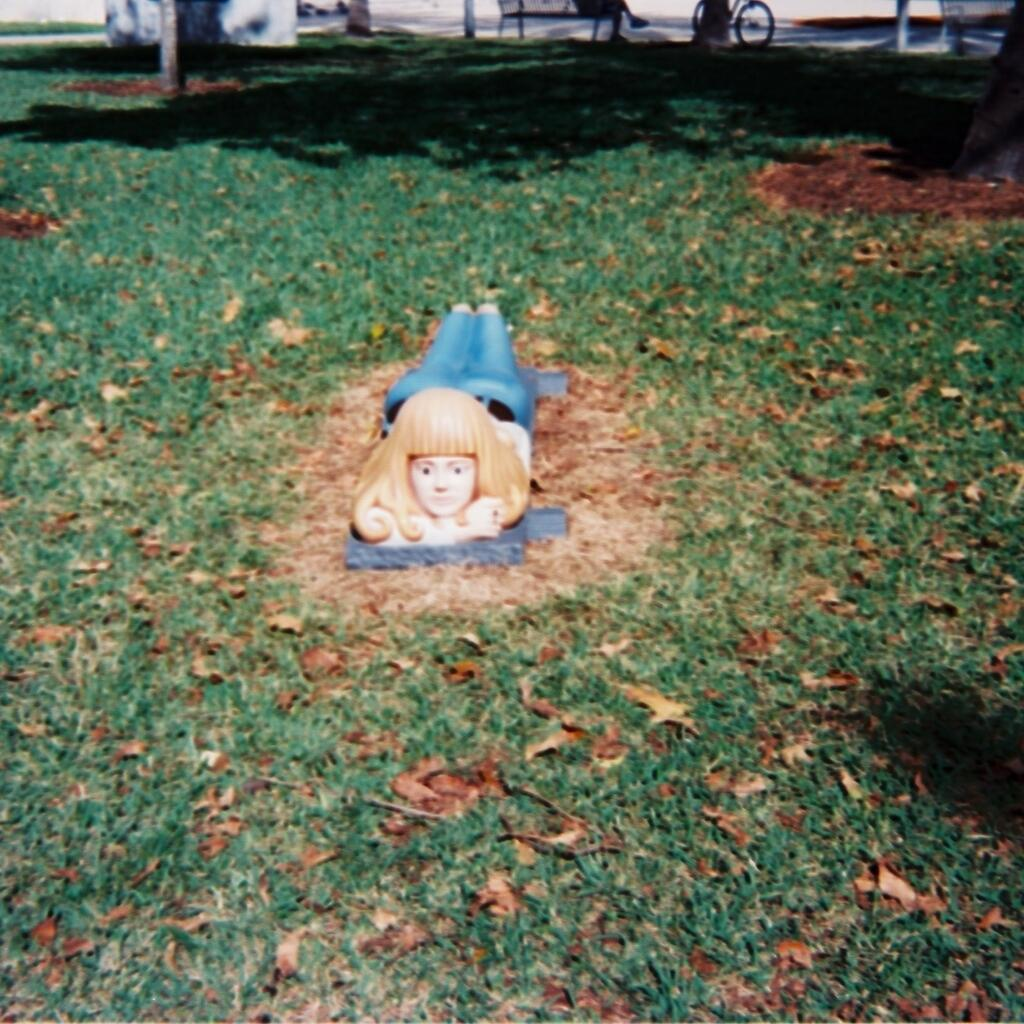What is the main subject in the middle of the image? There is a sculpture in the middle of the image. What type of vegetation can be seen in the image? There is grass visible in the image. What is the tax rate for mint in the image? There is no mention of mint or tax in the image, so it is not possible to determine the tax rate for mint. 